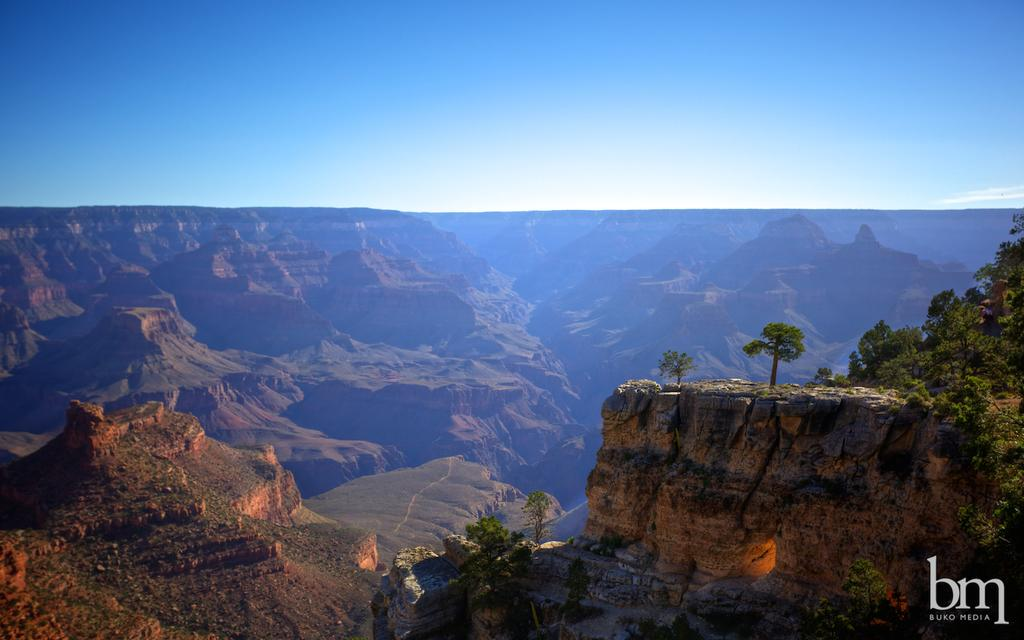What type of natural features can be seen in the image? There are hills and mountains in the image. Where are the majority of trees located in the image? There are many trees on the right side of the image. How many frogs can be seen sitting on the quince tree in the image? There are no frogs or quince trees present in the image. 